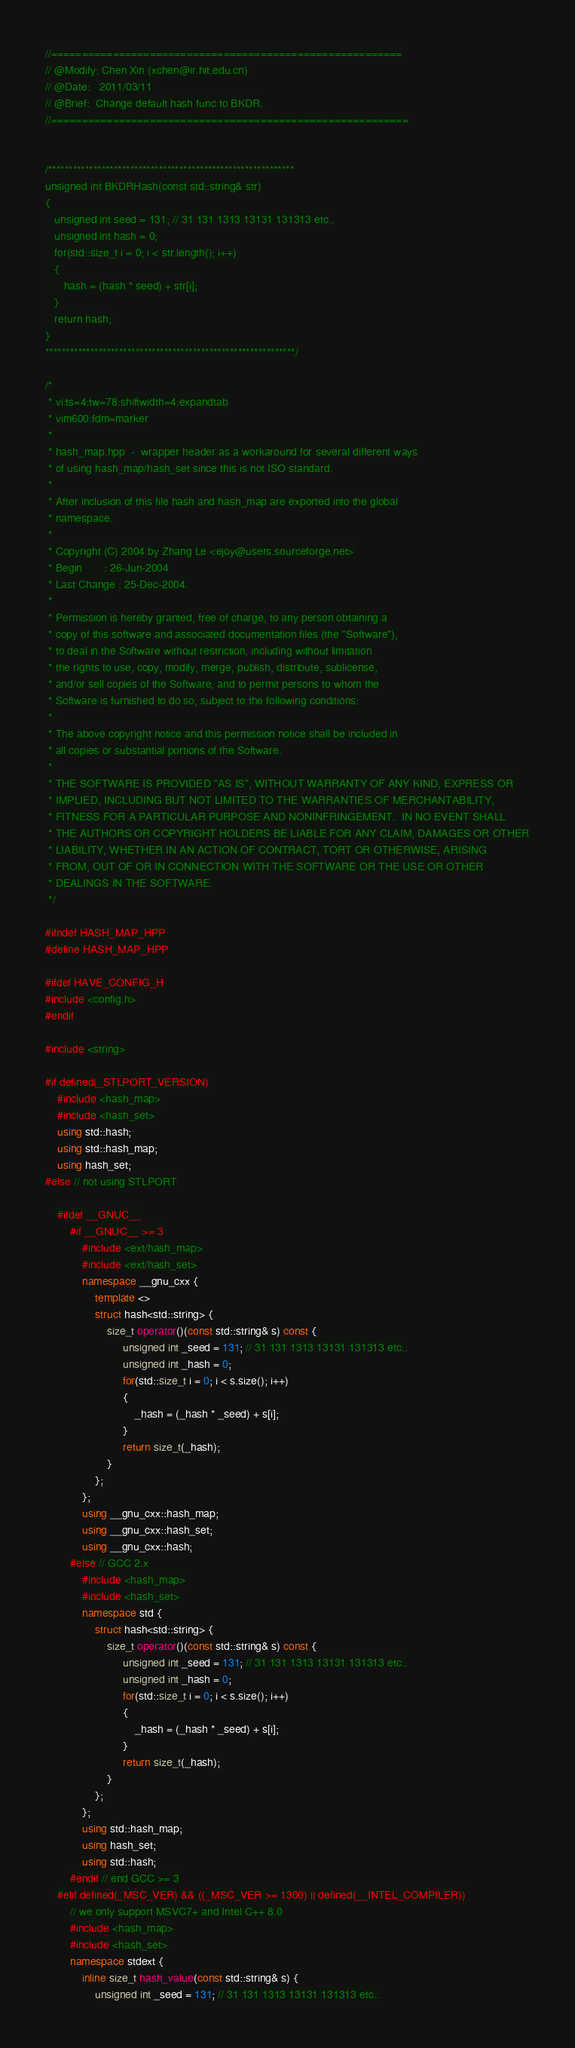<code> <loc_0><loc_0><loc_500><loc_500><_C++_>//=========================================================
// @Modify: Chen Xin (xchen@ir.hit.edu.cn)
// @Date:   2011/03/11
// @Brief:  Change default hash func to BKDR.
//==========================================================


/************************************************************
unsigned int BKDRHash(const std::string& str)
{
   unsigned int seed = 131; // 31 131 1313 13131 131313 etc..
   unsigned int hash = 0;
   for(std::size_t i = 0; i < str.length(); i++)
   {
      hash = (hash * seed) + str[i];
   }
   return hash;
}
*************************************************************/

/*
 * vi:ts=4:tw=78:shiftwidth=4:expandtab
 * vim600:fdm=marker
 *
 * hash_map.hpp  -  wrapper header as a workaround for several different ways
 * of using hash_map/hash_set since this is not ISO standard.
 *
 * After inclusion of this file hash and hash_map are exported into the global
 * namespace.
 *
 * Copyright (C) 2004 by Zhang Le <ejoy@users.sourceforge.net>
 * Begin       : 26-Jun-2004
 * Last Change : 25-Dec-2004.
 *
 * Permission is hereby granted, free of charge, to any person obtaining a
 * copy of this software and associated documentation files (the "Software"),
 * to deal in the Software without restriction, including without limitation
 * the rights to use, copy, modify, merge, publish, distribute, sublicense,
 * and/or sell copies of the Software, and to permit persons to whom the
 * Software is furnished to do so, subject to the following conditions:
 * 
 * The above copyright notice and this permission notice shall be included in
 * all copies or substantial portions of the Software.
 * 
 * THE SOFTWARE IS PROVIDED "AS IS", WITHOUT WARRANTY OF ANY KIND, EXPRESS OR
 * IMPLIED, INCLUDING BUT NOT LIMITED TO THE WARRANTIES OF MERCHANTABILITY,
 * FITNESS FOR A PARTICULAR PURPOSE AND NONINFRINGEMENT.  IN NO EVENT SHALL
 * THE AUTHORS OR COPYRIGHT HOLDERS BE LIABLE FOR ANY CLAIM, DAMAGES OR OTHER
 * LIABILITY, WHETHER IN AN ACTION OF CONTRACT, TORT OR OTHERWISE, ARISING
 * FROM, OUT OF OR IN CONNECTION WITH THE SOFTWARE OR THE USE OR OTHER
 * DEALINGS IN THE SOFTWARE.
 */

#ifndef HASH_MAP_HPP
#define HASH_MAP_HPP

#ifdef HAVE_CONFIG_H
#include <config.h>
#endif

#include <string>

#if defined(_STLPORT_VERSION)
    #include <hash_map>
    #include <hash_set>
    using std::hash;
    using std::hash_map;
    using hash_set;
#else // not using STLPORT

    #ifdef __GNUC__
        #if __GNUC__ >= 3
            #include <ext/hash_map>
            #include <ext/hash_set>
            namespace __gnu_cxx {
                template <>
                struct hash<std::string> {
                    size_t operator()(const std::string& s) const {
                         unsigned int _seed = 131; // 31 131 1313 13131 131313 etc..
						 unsigned int _hash = 0;
						 for(std::size_t i = 0; i < s.size(); i++)
						 {
						     _hash = (_hash * _seed) + s[i];
						 }
						 return size_t(_hash);
                    }
                };
            };
            using __gnu_cxx::hash_map;
			using __gnu_cxx::hash_set;
            using __gnu_cxx::hash;
        #else // GCC 2.x
            #include <hash_map>
            #include <hash_set>
            namespace std {
                struct hash<std::string> {
                    size_t operator()(const std::string& s) const {
                         unsigned int _seed = 131; // 31 131 1313 13131 131313 etc..
						 unsigned int _hash = 0;
						 for(std::size_t i = 0; i < s.size(); i++)
						 {
						     _hash = (_hash * _seed) + s[i];
						 }
						 return size_t(_hash);
                    }
                };
            };
            using std::hash_map;
            using hash_set;
            using std::hash;
        #endif // end GCC >= 3
    #elif defined(_MSC_VER) && ((_MSC_VER >= 1300) || defined(__INTEL_COMPILER))
        // we only support MSVC7+ and Intel C++ 8.0
        #include <hash_map>
        #include <hash_set>
        namespace stdext {
            inline size_t hash_value(const std::string& s) {
                unsigned int _seed = 131; // 31 131 1313 13131 131313 etc..</code> 